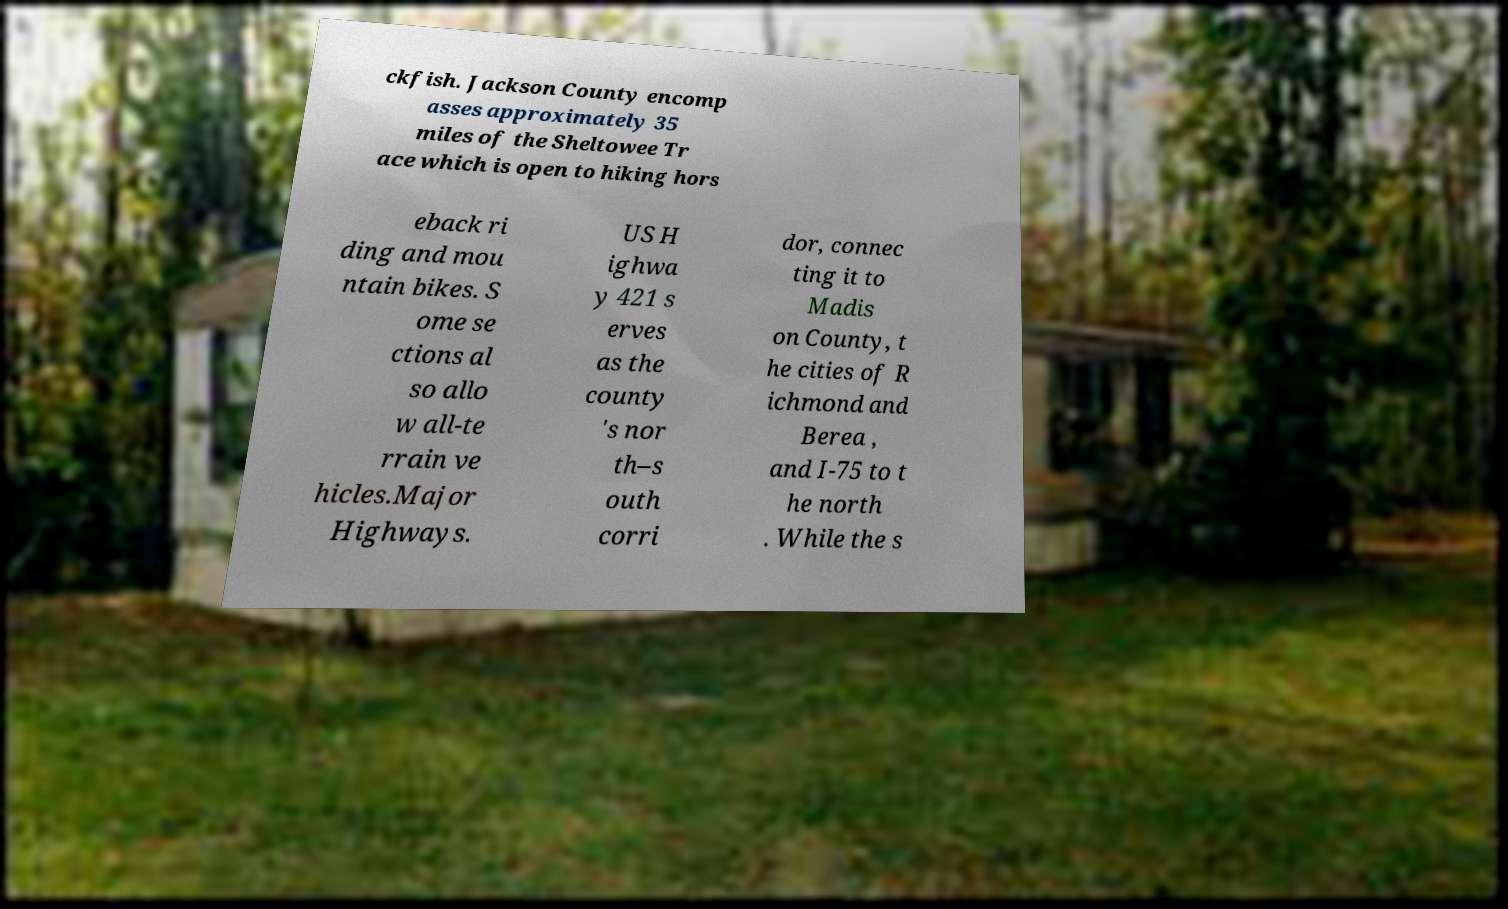Please read and relay the text visible in this image. What does it say? ckfish. Jackson County encomp asses approximately 35 miles of the Sheltowee Tr ace which is open to hiking hors eback ri ding and mou ntain bikes. S ome se ctions al so allo w all-te rrain ve hicles.Major Highways. US H ighwa y 421 s erves as the county 's nor th–s outh corri dor, connec ting it to Madis on County, t he cities of R ichmond and Berea , and I-75 to t he north . While the s 